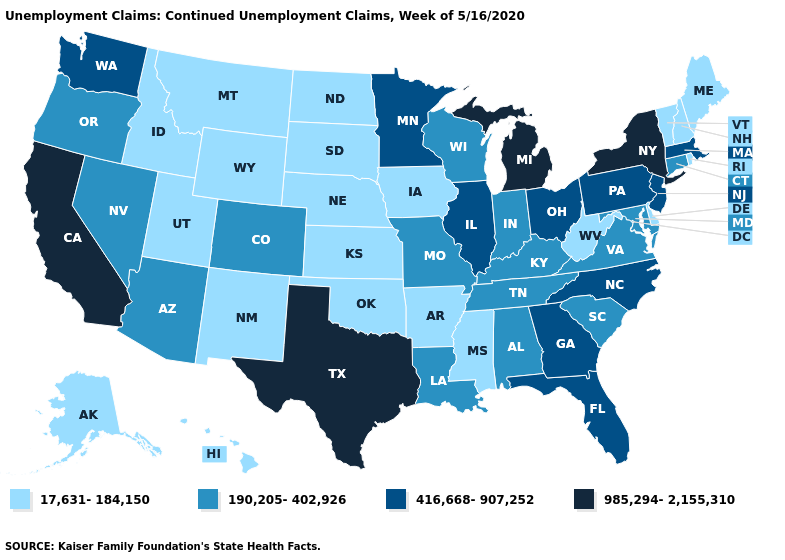Name the states that have a value in the range 190,205-402,926?
Short answer required. Alabama, Arizona, Colorado, Connecticut, Indiana, Kentucky, Louisiana, Maryland, Missouri, Nevada, Oregon, South Carolina, Tennessee, Virginia, Wisconsin. Name the states that have a value in the range 190,205-402,926?
Be succinct. Alabama, Arizona, Colorado, Connecticut, Indiana, Kentucky, Louisiana, Maryland, Missouri, Nevada, Oregon, South Carolina, Tennessee, Virginia, Wisconsin. How many symbols are there in the legend?
Be succinct. 4. What is the value of Oklahoma?
Short answer required. 17,631-184,150. Name the states that have a value in the range 985,294-2,155,310?
Answer briefly. California, Michigan, New York, Texas. Which states have the lowest value in the West?
Quick response, please. Alaska, Hawaii, Idaho, Montana, New Mexico, Utah, Wyoming. Is the legend a continuous bar?
Answer briefly. No. What is the value of Illinois?
Short answer required. 416,668-907,252. Is the legend a continuous bar?
Write a very short answer. No. Is the legend a continuous bar?
Give a very brief answer. No. What is the value of Kansas?
Concise answer only. 17,631-184,150. Does Vermont have the highest value in the USA?
Concise answer only. No. What is the highest value in the USA?
Answer briefly. 985,294-2,155,310. What is the value of Utah?
Concise answer only. 17,631-184,150. Is the legend a continuous bar?
Concise answer only. No. 